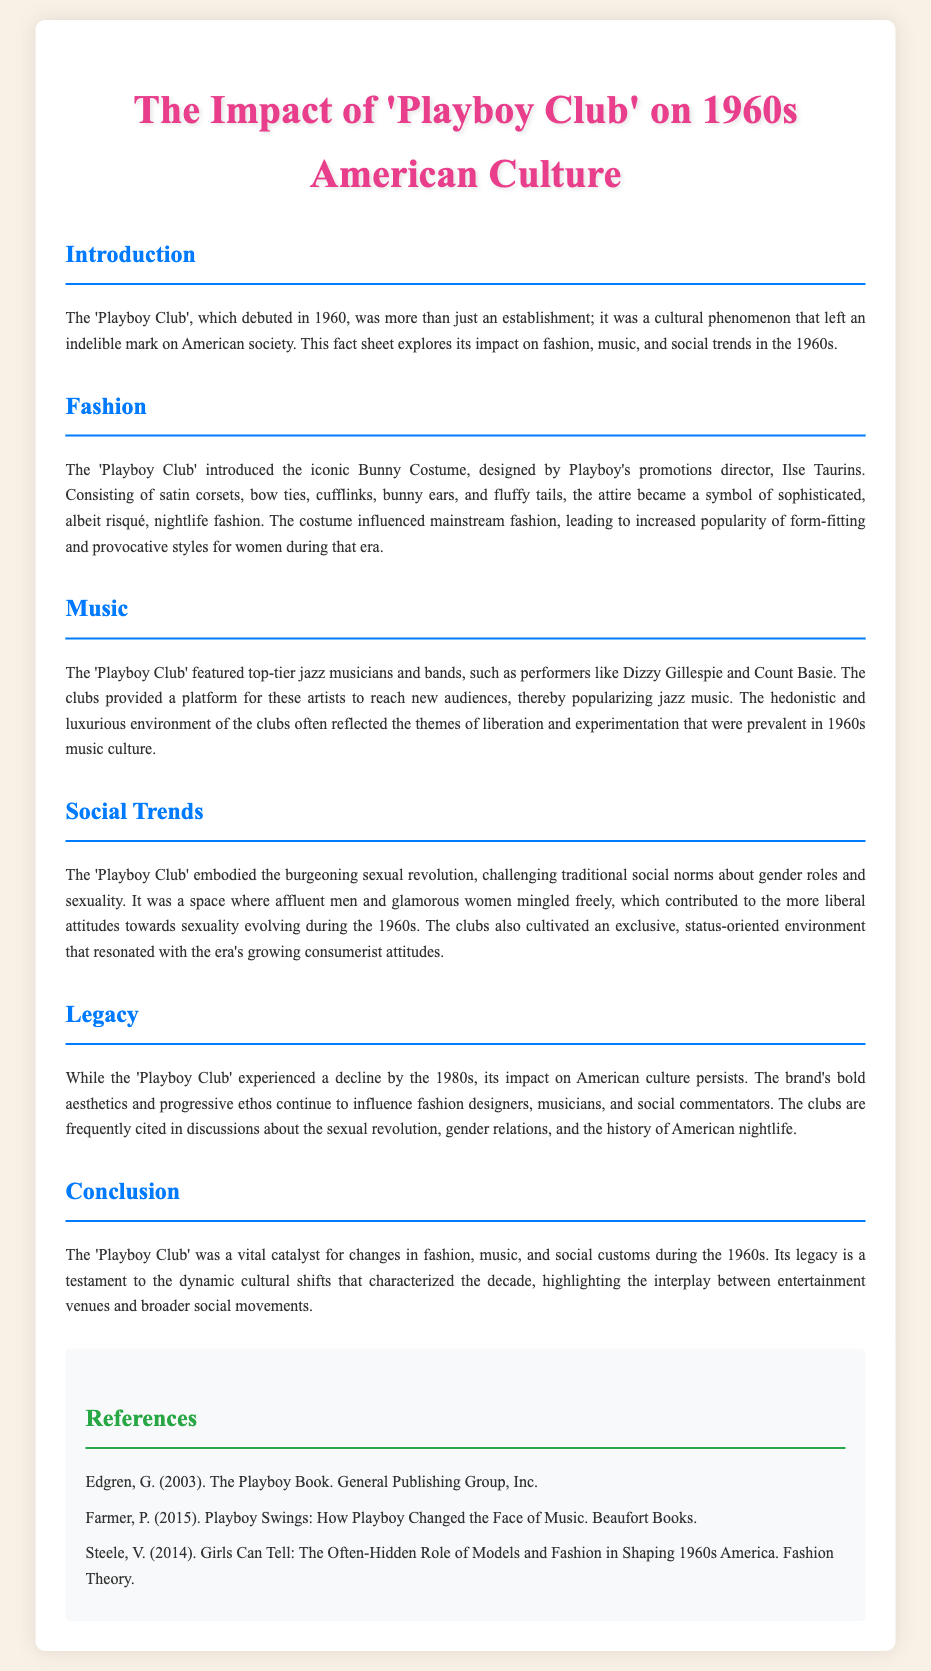What year did the 'Playboy Club' debut? The 'Playboy Club' debuted in 1960, as mentioned in the introduction of the document.
Answer: 1960 Who designed the Bunny Costume? The Bunny Costume was designed by Playboy's promotions director, Ilse Taurins, as stated in the fashion section.
Answer: Ilse Taurins What type of music was popularized at the 'Playboy Club'? The 'Playboy Club' popularized jazz music as highlighted in the music section.
Answer: Jazz Which two musicians were mentioned as performers at the 'Playboy Club'? The document mentions Dizzy Gillespie and Count Basie as artists who performed at the club.
Answer: Dizzy Gillespie and Count Basie What social movement did the 'Playboy Club' signify during the 1960s? The 'Playboy Club' embodied the burgeoning sexual revolution, as described in the social trends section.
Answer: Sexual revolution What fashion element became a symbol of nightlife at the 'Playboy Club'? The Bunny Costume became a symbol of sophisticated nightlife fashion mentioned in the fashion section.
Answer: Bunny Costume What type of environment did the 'Playboy Club' promote? The club promoted a luxurious and hedonistic environment, reflecting themes of liberation.
Answer: Luxurious and hedonistic In which decade did the 'Playboy Club' have a lasting legacy? The legacy of the 'Playboy Club' is discussed in connection with American culture during the 1960s.
Answer: 1960s 